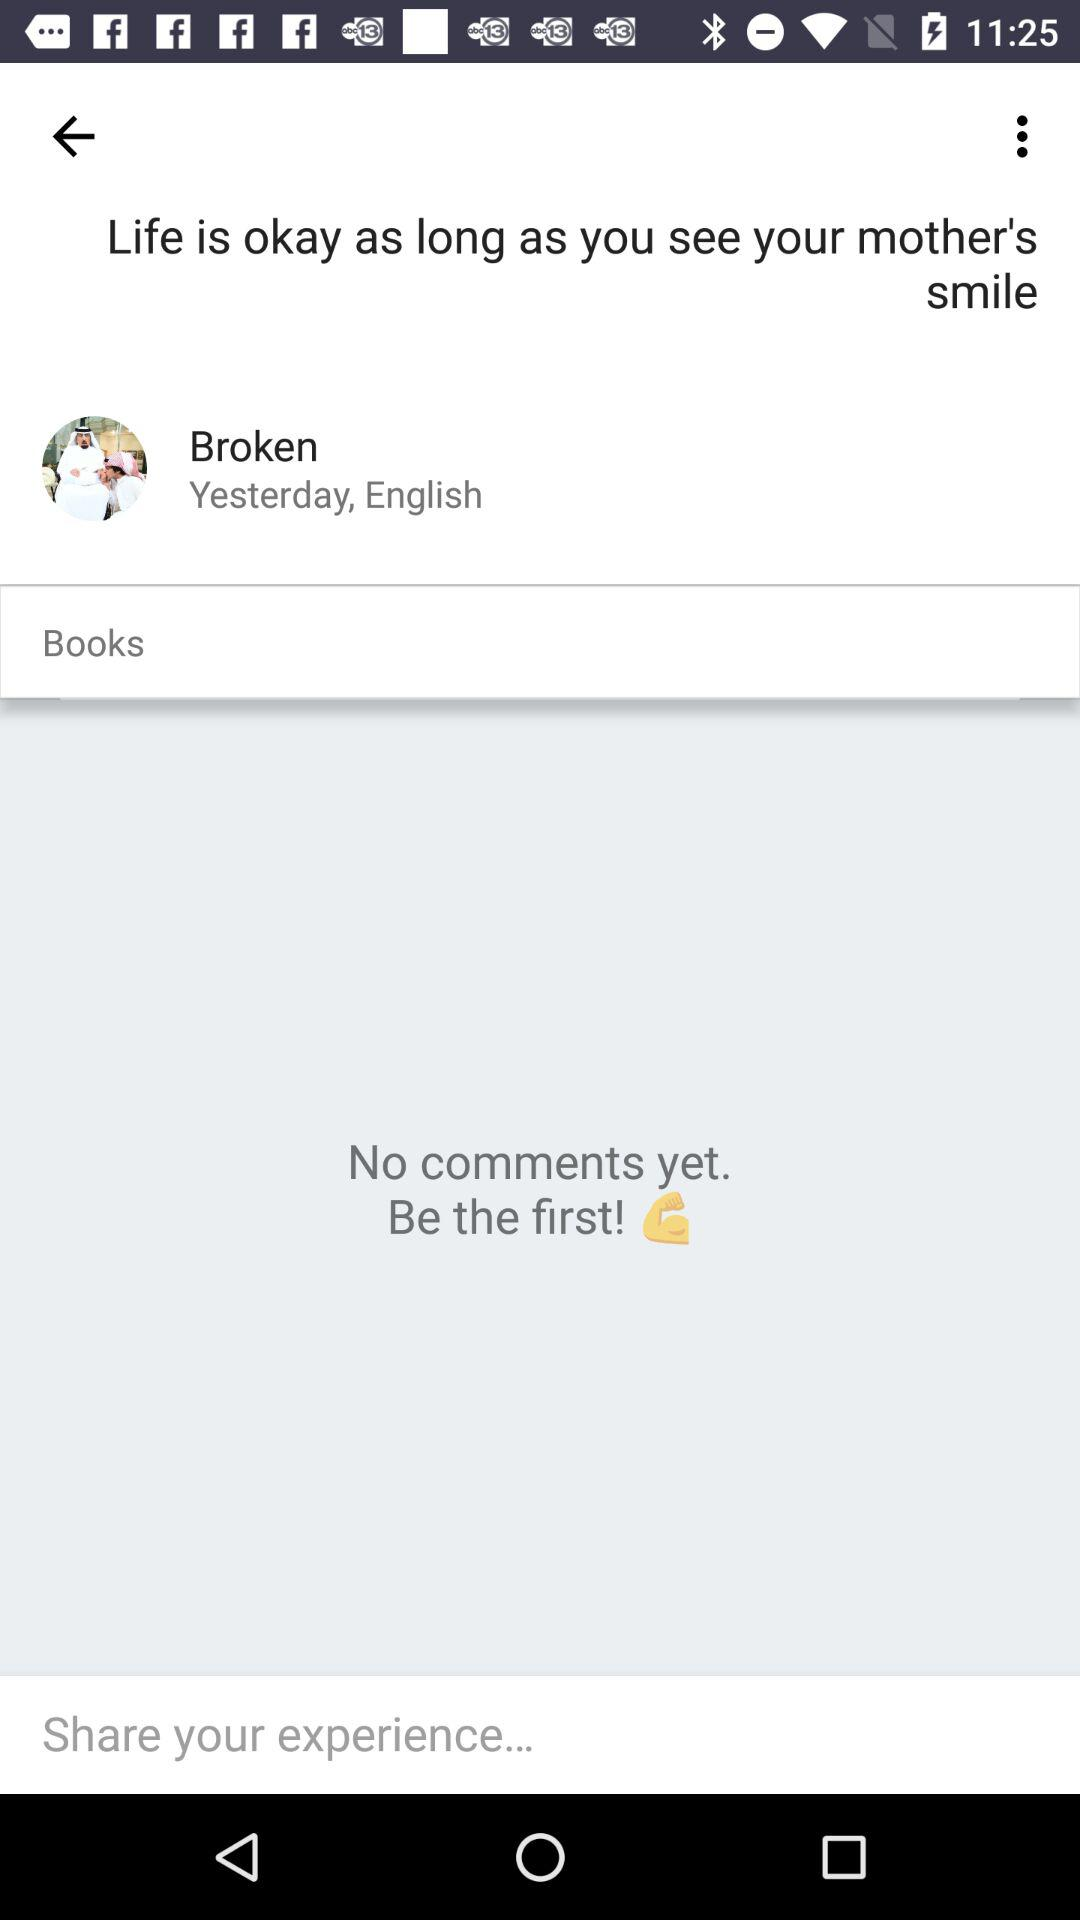How many books are there?
When the provided information is insufficient, respond with <no answer>. <no answer> 